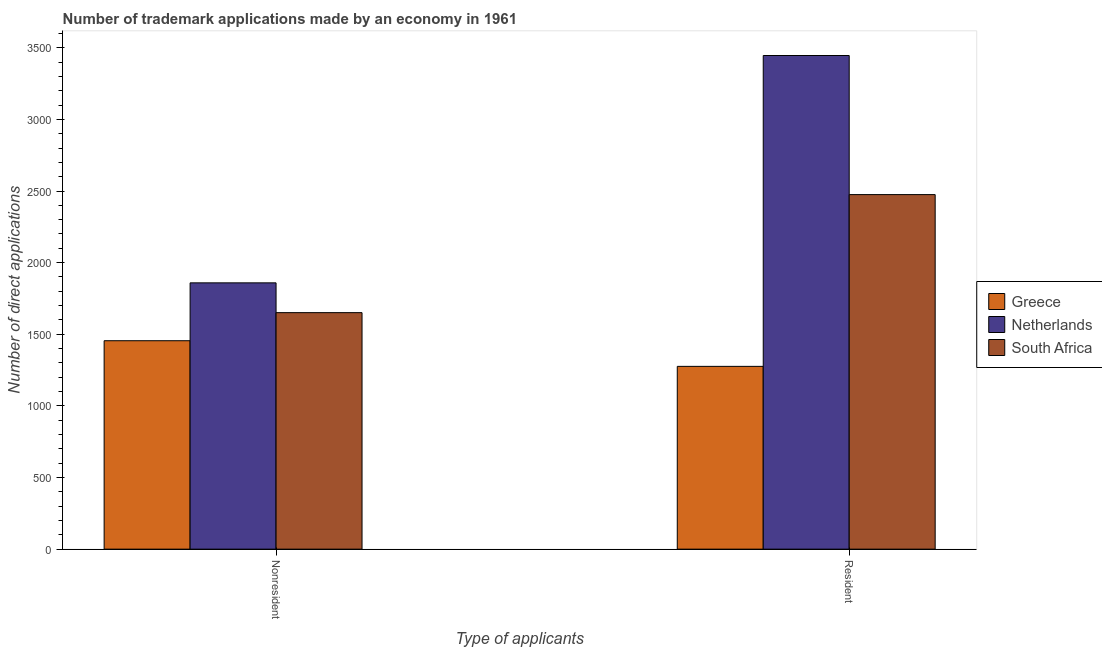How many different coloured bars are there?
Offer a very short reply. 3. How many groups of bars are there?
Give a very brief answer. 2. Are the number of bars on each tick of the X-axis equal?
Give a very brief answer. Yes. How many bars are there on the 2nd tick from the right?
Give a very brief answer. 3. What is the label of the 2nd group of bars from the left?
Your answer should be compact. Resident. What is the number of trademark applications made by non residents in Greece?
Offer a very short reply. 1455. Across all countries, what is the maximum number of trademark applications made by non residents?
Your response must be concise. 1859. Across all countries, what is the minimum number of trademark applications made by non residents?
Your answer should be very brief. 1455. In which country was the number of trademark applications made by residents minimum?
Keep it short and to the point. Greece. What is the total number of trademark applications made by non residents in the graph?
Ensure brevity in your answer.  4965. What is the difference between the number of trademark applications made by residents in Netherlands and that in Greece?
Offer a terse response. 2170. What is the difference between the number of trademark applications made by residents in Greece and the number of trademark applications made by non residents in South Africa?
Keep it short and to the point. -375. What is the average number of trademark applications made by residents per country?
Offer a very short reply. 2399. What is the difference between the number of trademark applications made by residents and number of trademark applications made by non residents in South Africa?
Keep it short and to the point. 824. In how many countries, is the number of trademark applications made by non residents greater than 800 ?
Offer a very short reply. 3. What is the ratio of the number of trademark applications made by non residents in South Africa to that in Netherlands?
Keep it short and to the point. 0.89. What does the 1st bar from the right in Nonresident represents?
Your answer should be compact. South Africa. How many bars are there?
Make the answer very short. 6. Are all the bars in the graph horizontal?
Offer a very short reply. No. How many countries are there in the graph?
Ensure brevity in your answer.  3. Does the graph contain any zero values?
Your answer should be very brief. No. How many legend labels are there?
Offer a very short reply. 3. What is the title of the graph?
Provide a succinct answer. Number of trademark applications made by an economy in 1961. What is the label or title of the X-axis?
Provide a succinct answer. Type of applicants. What is the label or title of the Y-axis?
Make the answer very short. Number of direct applications. What is the Number of direct applications of Greece in Nonresident?
Your response must be concise. 1455. What is the Number of direct applications in Netherlands in Nonresident?
Provide a succinct answer. 1859. What is the Number of direct applications of South Africa in Nonresident?
Give a very brief answer. 1651. What is the Number of direct applications in Greece in Resident?
Ensure brevity in your answer.  1276. What is the Number of direct applications of Netherlands in Resident?
Offer a terse response. 3446. What is the Number of direct applications of South Africa in Resident?
Ensure brevity in your answer.  2475. Across all Type of applicants, what is the maximum Number of direct applications in Greece?
Ensure brevity in your answer.  1455. Across all Type of applicants, what is the maximum Number of direct applications of Netherlands?
Provide a short and direct response. 3446. Across all Type of applicants, what is the maximum Number of direct applications of South Africa?
Ensure brevity in your answer.  2475. Across all Type of applicants, what is the minimum Number of direct applications of Greece?
Your response must be concise. 1276. Across all Type of applicants, what is the minimum Number of direct applications of Netherlands?
Your answer should be compact. 1859. Across all Type of applicants, what is the minimum Number of direct applications in South Africa?
Your response must be concise. 1651. What is the total Number of direct applications of Greece in the graph?
Provide a short and direct response. 2731. What is the total Number of direct applications in Netherlands in the graph?
Offer a very short reply. 5305. What is the total Number of direct applications of South Africa in the graph?
Provide a succinct answer. 4126. What is the difference between the Number of direct applications in Greece in Nonresident and that in Resident?
Your response must be concise. 179. What is the difference between the Number of direct applications in Netherlands in Nonresident and that in Resident?
Offer a terse response. -1587. What is the difference between the Number of direct applications in South Africa in Nonresident and that in Resident?
Your response must be concise. -824. What is the difference between the Number of direct applications in Greece in Nonresident and the Number of direct applications in Netherlands in Resident?
Make the answer very short. -1991. What is the difference between the Number of direct applications in Greece in Nonresident and the Number of direct applications in South Africa in Resident?
Offer a very short reply. -1020. What is the difference between the Number of direct applications in Netherlands in Nonresident and the Number of direct applications in South Africa in Resident?
Offer a very short reply. -616. What is the average Number of direct applications in Greece per Type of applicants?
Ensure brevity in your answer.  1365.5. What is the average Number of direct applications in Netherlands per Type of applicants?
Provide a short and direct response. 2652.5. What is the average Number of direct applications in South Africa per Type of applicants?
Make the answer very short. 2063. What is the difference between the Number of direct applications of Greece and Number of direct applications of Netherlands in Nonresident?
Keep it short and to the point. -404. What is the difference between the Number of direct applications of Greece and Number of direct applications of South Africa in Nonresident?
Make the answer very short. -196. What is the difference between the Number of direct applications of Netherlands and Number of direct applications of South Africa in Nonresident?
Your response must be concise. 208. What is the difference between the Number of direct applications of Greece and Number of direct applications of Netherlands in Resident?
Keep it short and to the point. -2170. What is the difference between the Number of direct applications in Greece and Number of direct applications in South Africa in Resident?
Provide a succinct answer. -1199. What is the difference between the Number of direct applications in Netherlands and Number of direct applications in South Africa in Resident?
Your answer should be very brief. 971. What is the ratio of the Number of direct applications in Greece in Nonresident to that in Resident?
Your response must be concise. 1.14. What is the ratio of the Number of direct applications in Netherlands in Nonresident to that in Resident?
Your answer should be very brief. 0.54. What is the ratio of the Number of direct applications of South Africa in Nonresident to that in Resident?
Your answer should be compact. 0.67. What is the difference between the highest and the second highest Number of direct applications in Greece?
Keep it short and to the point. 179. What is the difference between the highest and the second highest Number of direct applications of Netherlands?
Offer a very short reply. 1587. What is the difference between the highest and the second highest Number of direct applications in South Africa?
Your answer should be compact. 824. What is the difference between the highest and the lowest Number of direct applications in Greece?
Keep it short and to the point. 179. What is the difference between the highest and the lowest Number of direct applications of Netherlands?
Ensure brevity in your answer.  1587. What is the difference between the highest and the lowest Number of direct applications of South Africa?
Ensure brevity in your answer.  824. 